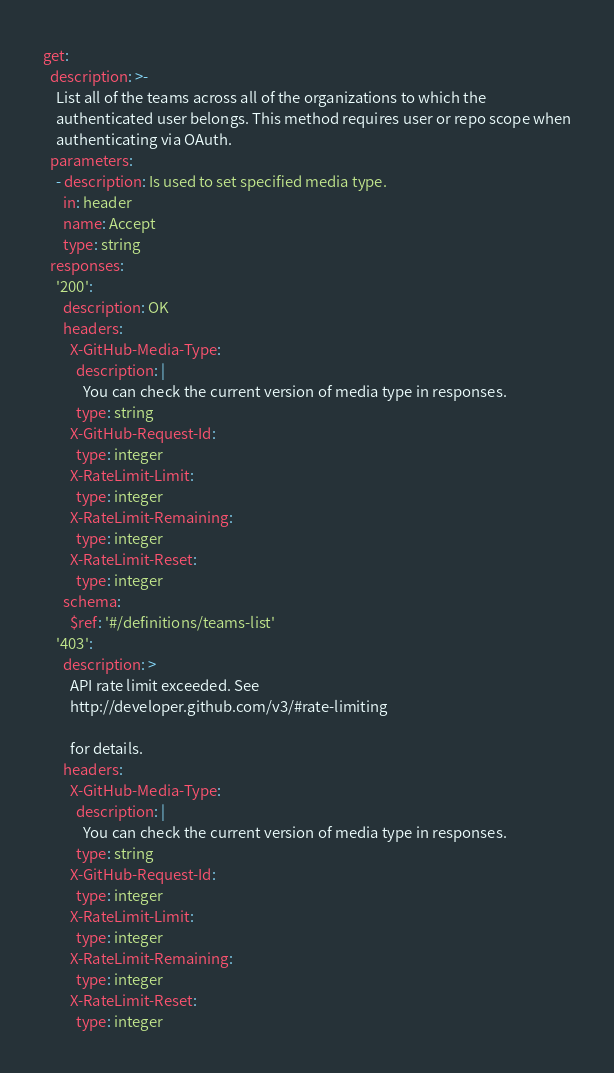<code> <loc_0><loc_0><loc_500><loc_500><_YAML_>get:
  description: >-
    List all of the teams across all of the organizations to which the
    authenticated user belongs. This method requires user or repo scope when
    authenticating via OAuth.
  parameters:
    - description: Is used to set specified media type.
      in: header
      name: Accept
      type: string
  responses:
    '200':
      description: OK
      headers:
        X-GitHub-Media-Type:
          description: |
            You can check the current version of media type in responses.
          type: string
        X-GitHub-Request-Id:
          type: integer
        X-RateLimit-Limit:
          type: integer
        X-RateLimit-Remaining:
          type: integer
        X-RateLimit-Reset:
          type: integer
      schema:
        $ref: '#/definitions/teams-list'
    '403':
      description: >
        API rate limit exceeded. See
        http://developer.github.com/v3/#rate-limiting

        for details.
      headers:
        X-GitHub-Media-Type:
          description: |
            You can check the current version of media type in responses.
          type: string
        X-GitHub-Request-Id:
          type: integer
        X-RateLimit-Limit:
          type: integer
        X-RateLimit-Remaining:
          type: integer
        X-RateLimit-Reset:
          type: integer
</code> 